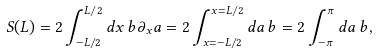<formula> <loc_0><loc_0><loc_500><loc_500>S ( L ) = 2 \int _ { - L / 2 } ^ { L / 2 } d x \, b \partial _ { x } a = 2 \int _ { x = - L / 2 } ^ { x = L / 2 } d a \, b = 2 \int _ { - \pi } ^ { \pi } d a \, b ,</formula> 